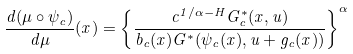Convert formula to latex. <formula><loc_0><loc_0><loc_500><loc_500>\frac { d ( \mu \circ \psi _ { c } ) } { d \mu } ( x ) = \left \{ \frac { c ^ { 1 / \alpha - H } G _ { c } ^ { * } ( x , u ) } { b _ { c } ( x ) G ^ { * } ( \psi _ { c } ( x ) , u + g _ { c } ( x ) ) } \right \} ^ { \alpha }</formula> 